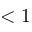<formula> <loc_0><loc_0><loc_500><loc_500>< 1</formula> 